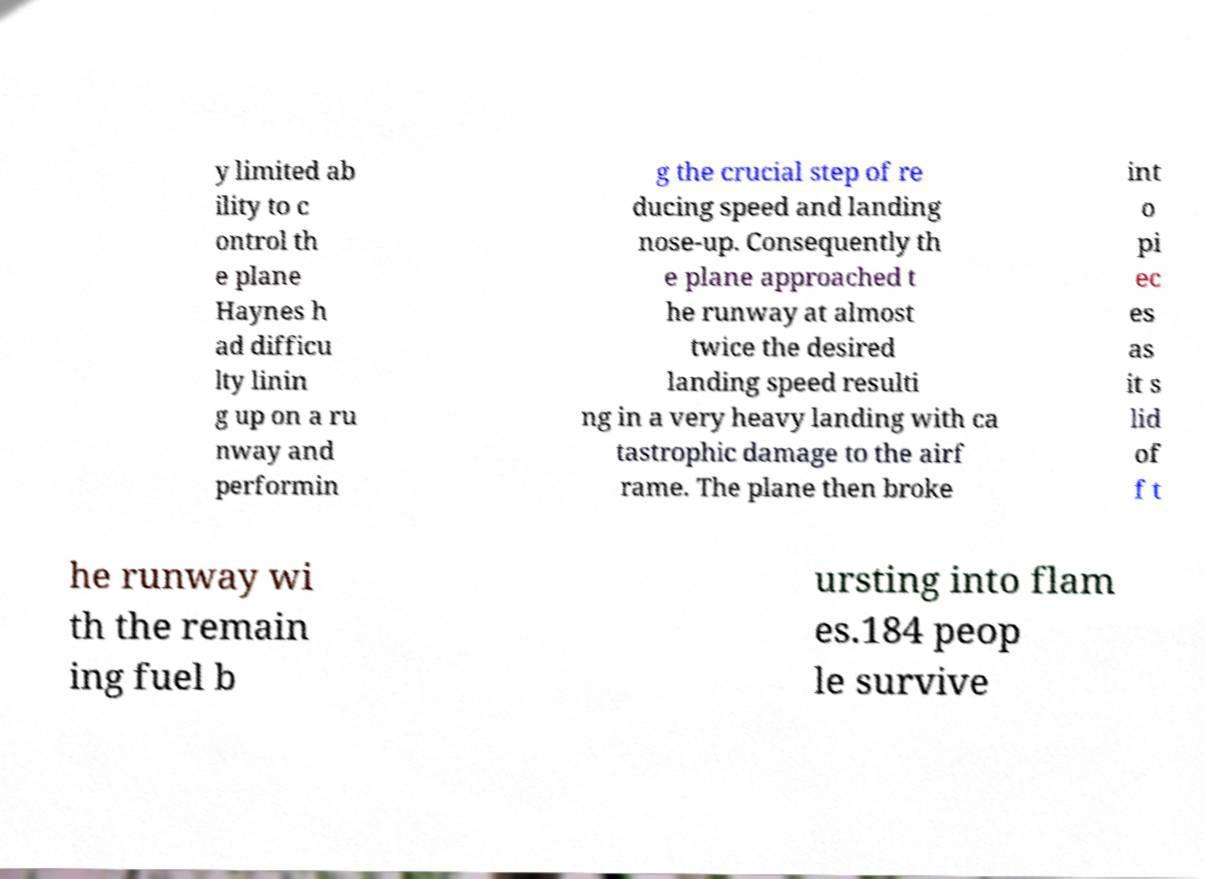Could you extract and type out the text from this image? y limited ab ility to c ontrol th e plane Haynes h ad difficu lty linin g up on a ru nway and performin g the crucial step of re ducing speed and landing nose-up. Consequently th e plane approached t he runway at almost twice the desired landing speed resulti ng in a very heavy landing with ca tastrophic damage to the airf rame. The plane then broke int o pi ec es as it s lid of f t he runway wi th the remain ing fuel b ursting into flam es.184 peop le survive 